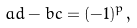<formula> <loc_0><loc_0><loc_500><loc_500>a d - b c = ( - 1 ) ^ { p } ,</formula> 